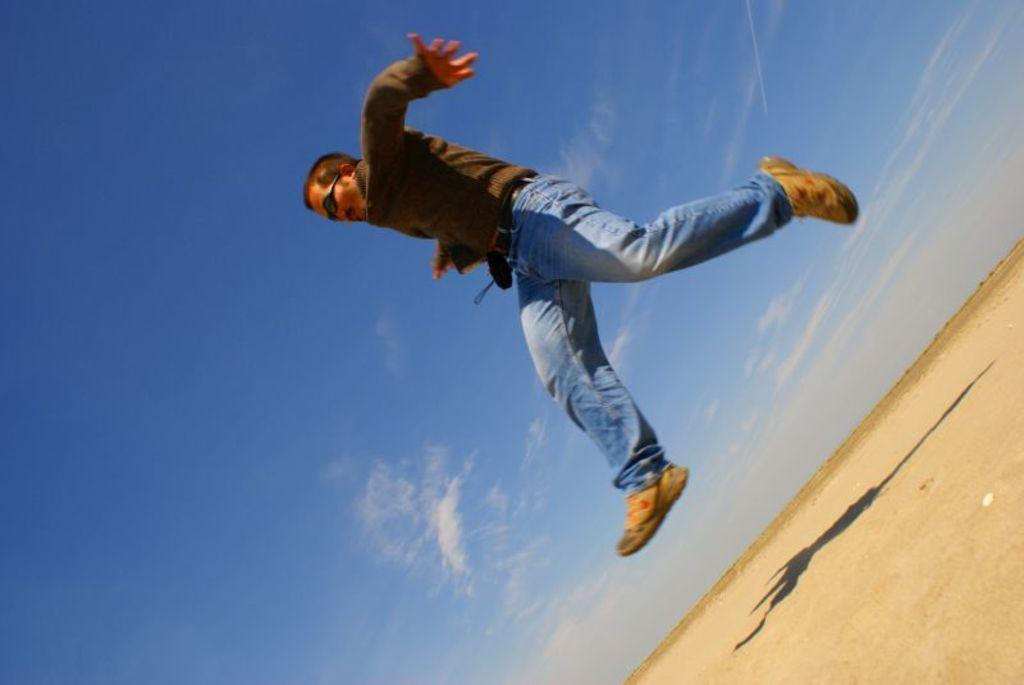What is the main subject of the image? There is a person in the image. What is the person wearing? The person is wearing sunglasses. What is the person doing in the image? The person is jumping on the ground. What can be seen on the ground due to the person's presence? There is a shadow of the person on the ground. What is visible in the background of the image? There are clouds in the sky in the background of the image. What type of love can be seen in the person's eyes in the image? There is no indication of love or emotion in the person's eyes in the image, as sunglasses are covering their eyes. What kind of doll is sitting next to the person in the image? There is no doll present in the image; it only features a person jumping on the ground. 